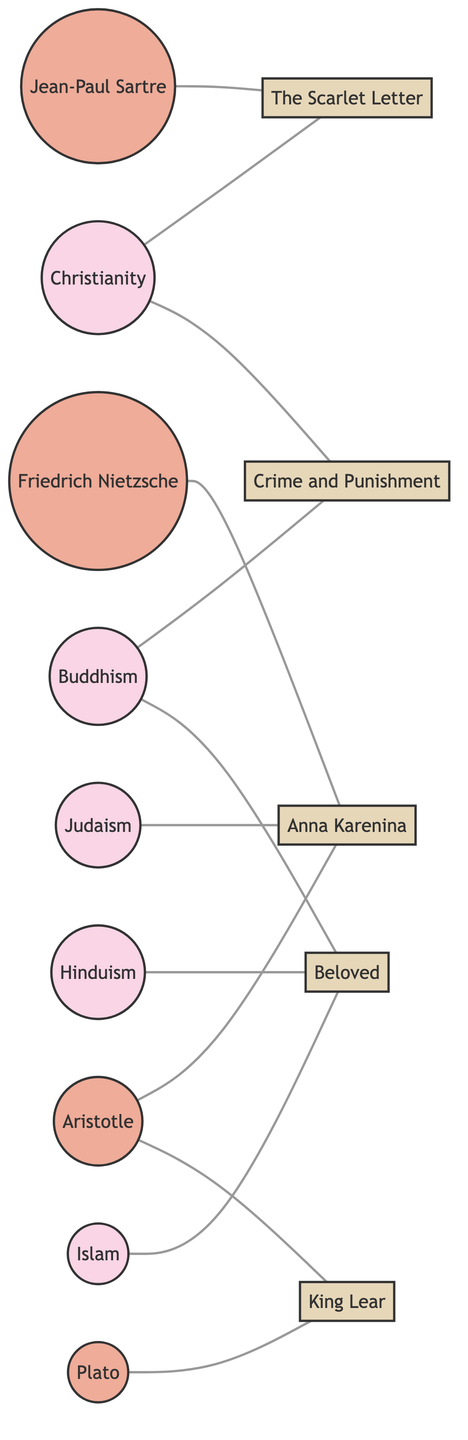What is the total number of nodes in the diagram? By counting each labeled object in the diagram, we identify that there are 14 distinct nodes present, representing different religions, philosophies, and literary works.
Answer: 14 Which religion is connected to "Crime and Punishment"? Observing the edges, "Crime and Punishment" is linked to both Christianity and Buddhism, as marked in the connections.
Answer: Christianity, Buddhism Who is connected to "King Lear"? Checking the edges, we see that both Plato and Aristotle are connected to "King Lear", which indicates their philosophical influence on this literary work.
Answer: Plato, Aristotle How many philosophical ideologies are represented in the diagram? By identifying the nodes categorized under "Philosophy", we find there are 4 distinct philosophical ideologies: Plato, Aristotle, Friedrich Nietzsche, and Jean-Paul Sartre.
Answer: 4 Which literary work is influenced by both Islam and Buddhism? Upon examining the connections, we see "Beloved" is associated with both the Islam and Buddhism nodes, showcasing a multi-faceted impact of these ideologies on the theme of redemption in this work.
Answer: Beloved Which literary work connects to the most religious ideologies? Analyzing the edges shows that "Beloved" is connected to three religious ideologies: Islam, Buddhism, and Hinduism, making it the literary work with the most religious connections.
Answer: Beloved What is the relationship between Nietzsche and "Anna Karenina"? Reviewing the diagram, there are no direct connections (edges) linking Friedrich Nietzsche to "Anna Karenina", indicating that Nietzsche's philosophy may not significantly influence this literary work.
Answer: No direct relationship Which philosopher’s ideas are connected to the highest number of literary works? By checking the connections, Aristotle is linked to two literary works: "King Lear" and "Anna Karenina", making him the philosopher with the most literary influences in this diagram.
Answer: Aristotle 